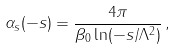Convert formula to latex. <formula><loc_0><loc_0><loc_500><loc_500>\alpha _ { s } ( - s ) = \frac { 4 \pi } { \beta _ { 0 } \ln ( - s / \Lambda ^ { 2 } ) } \, ,</formula> 